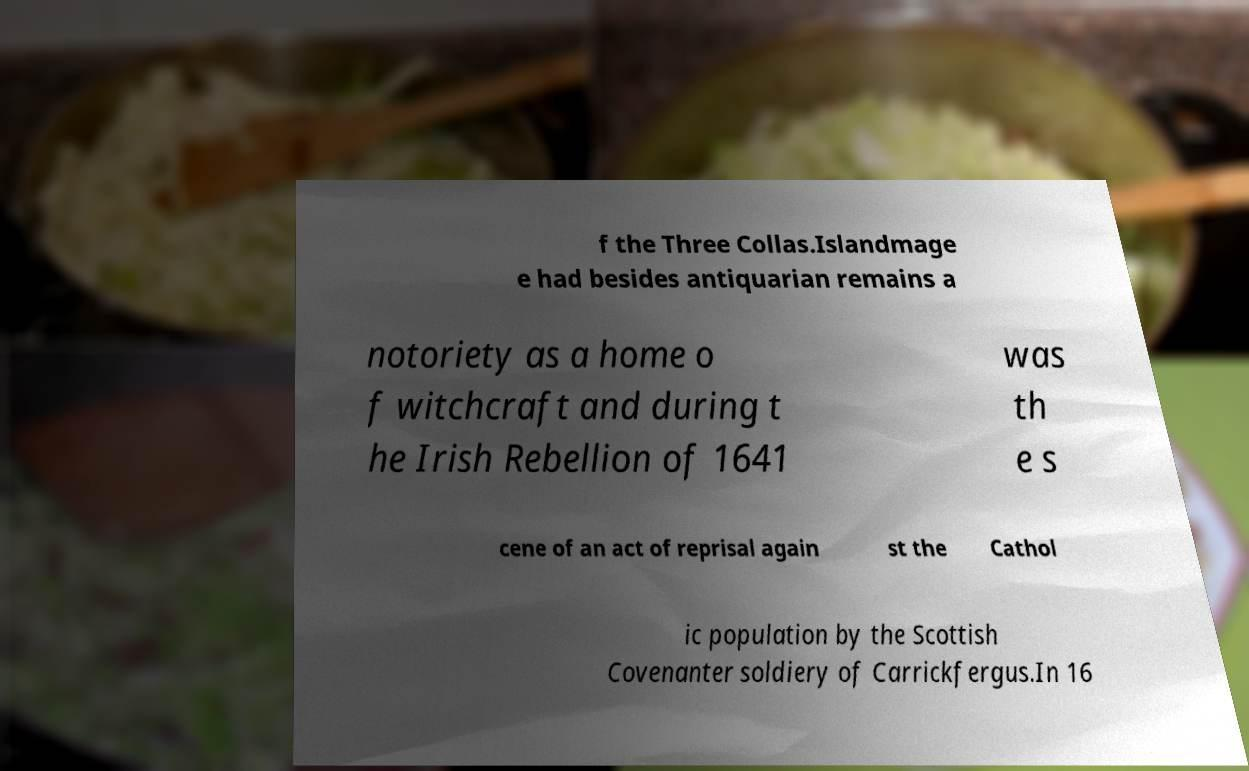Can you accurately transcribe the text from the provided image for me? f the Three Collas.Islandmage e had besides antiquarian remains a notoriety as a home o f witchcraft and during t he Irish Rebellion of 1641 was th e s cene of an act of reprisal again st the Cathol ic population by the Scottish Covenanter soldiery of Carrickfergus.In 16 